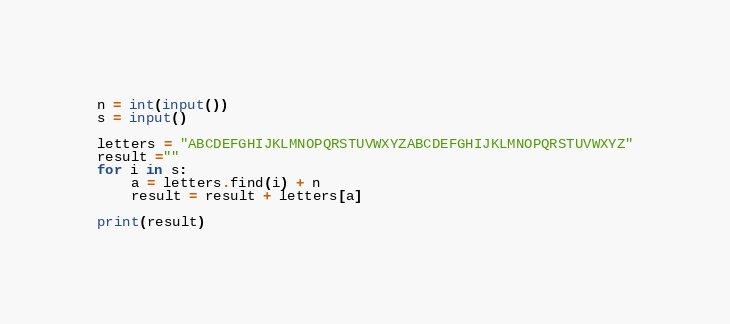Convert code to text. <code><loc_0><loc_0><loc_500><loc_500><_Python_>n = int(input())
s = input()

letters = "ABCDEFGHIJKLMNOPQRSTUVWXYZABCDEFGHIJKLMNOPQRSTUVWXYZ"
result =""
for i in s:
    a = letters.find(i) + n
    result = result + letters[a]
    
print(result)</code> 